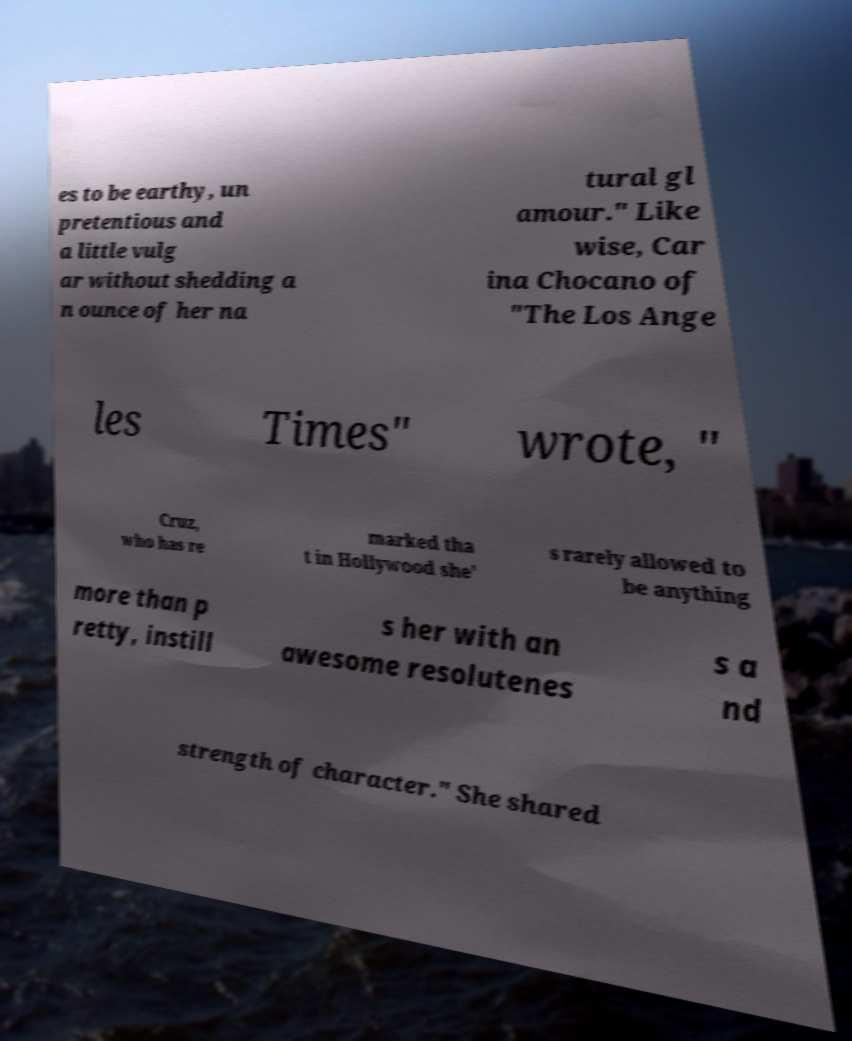Could you extract and type out the text from this image? es to be earthy, un pretentious and a little vulg ar without shedding a n ounce of her na tural gl amour." Like wise, Car ina Chocano of "The Los Ange les Times" wrote, " Cruz, who has re marked tha t in Hollywood she' s rarely allowed to be anything more than p retty, instill s her with an awesome resolutenes s a nd strength of character." She shared 